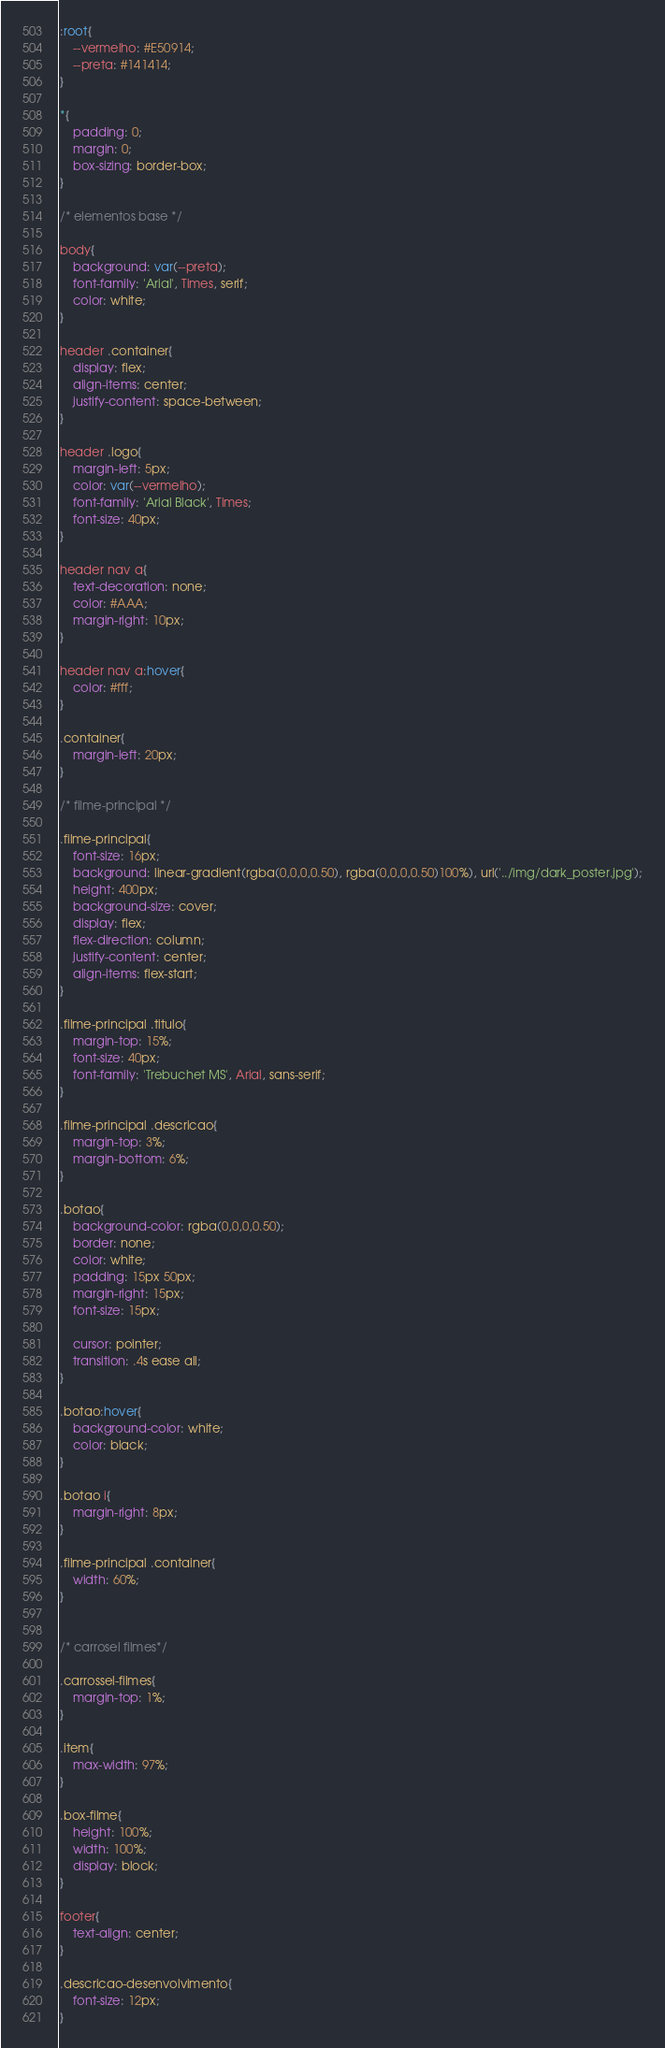Convert code to text. <code><loc_0><loc_0><loc_500><loc_500><_CSS_>:root{
    --vermelho: #E50914;
    --preta: #141414;
}

*{
    padding: 0;
    margin: 0;
    box-sizing: border-box;
}

/* elementos base */

body{
    background: var(--preta);
    font-family: 'Arial', Times, serif;
    color: white;
}

header .container{
    display: flex;
    align-items: center;
    justify-content: space-between;
}

header .logo{
    margin-left: 5px;
    color: var(--vermelho);
    font-family: 'Arial Black', Times;
    font-size: 40px;
}

header nav a{
    text-decoration: none;
    color: #AAA;
    margin-right: 10px;    
}

header nav a:hover{
    color: #fff;
}

.container{
    margin-left: 20px;
}

/* filme-principal */

.filme-principal{
    font-size: 16px;
    background: linear-gradient(rgba(0,0,0,0.50), rgba(0,0,0,0.50)100%), url('../img/dark_poster.jpg');
    height: 400px;
    background-size: cover;
    display: flex;
    flex-direction: column;
    justify-content: center;
    align-items: flex-start;
}

.filme-principal .titulo{
    margin-top: 15%;
    font-size: 40px;
    font-family: 'Trebuchet MS', Arial, sans-serif;
}

.filme-principal .descricao{
    margin-top: 3%;
    margin-bottom: 6%;
}

.botao{
    background-color: rgba(0,0,0,0.50);
    border: none;
    color: white;
    padding: 15px 50px;
    margin-right: 15px;
    font-size: 15px;

    cursor: pointer;    
    transition: .4s ease all;
}

.botao:hover{
    background-color: white;
    color: black;
}

.botao i{
    margin-right: 8px;
}

.filme-principal .container{
    width: 60%;
}


/* carrosel filmes*/

.carrossel-filmes{
    margin-top: 1%;
}

.item{
    max-width: 97%;
}

.box-filme{
    height: 100%;
    width: 100%;
    display: block;
}

footer{
    text-align: center;
}

.descricao-desenvolvimento{
    font-size: 12px;
}</code> 